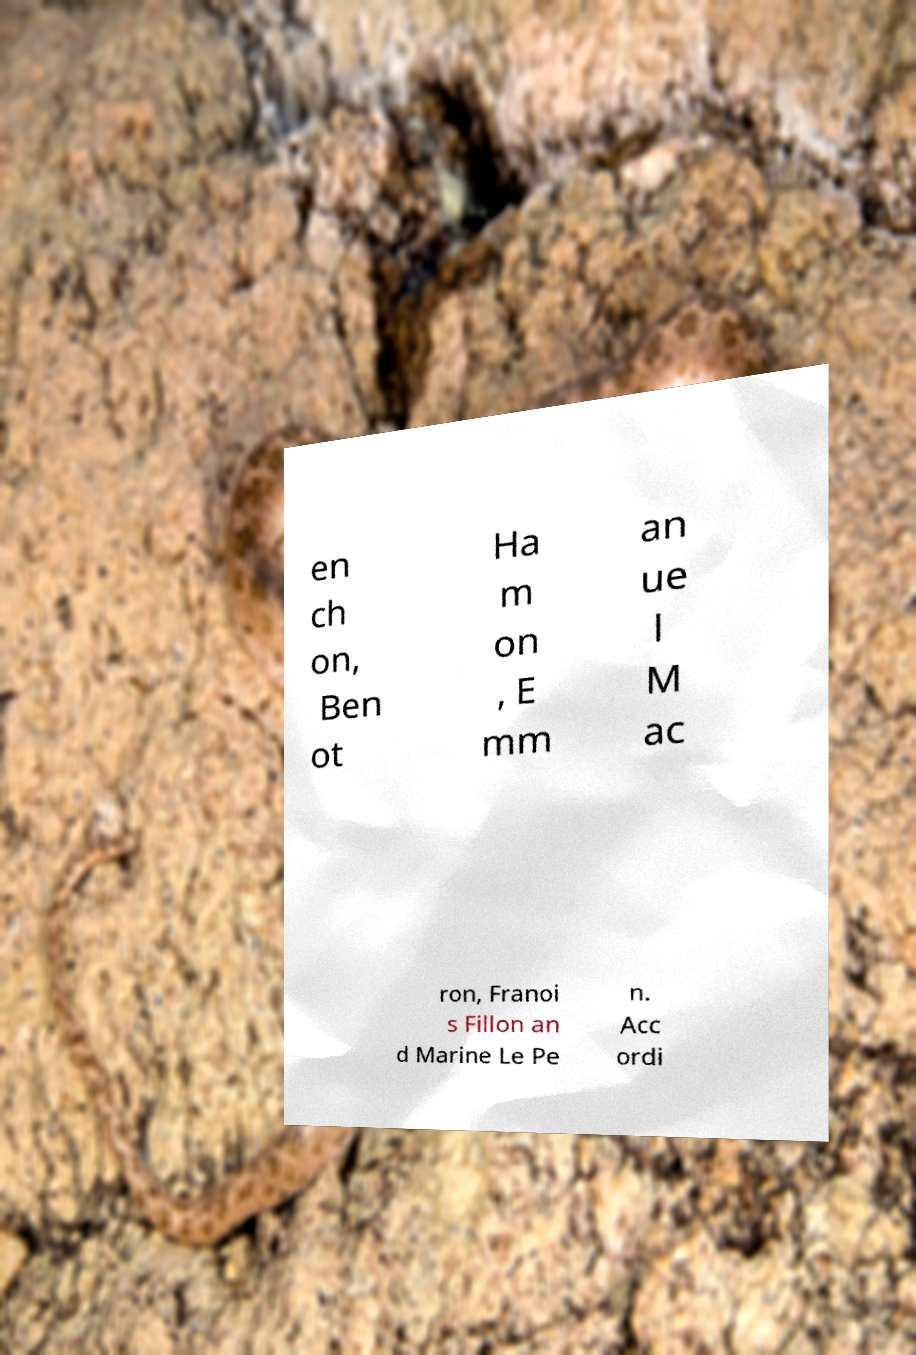Can you read and provide the text displayed in the image?This photo seems to have some interesting text. Can you extract and type it out for me? en ch on, Ben ot Ha m on , E mm an ue l M ac ron, Franoi s Fillon an d Marine Le Pe n. Acc ordi 